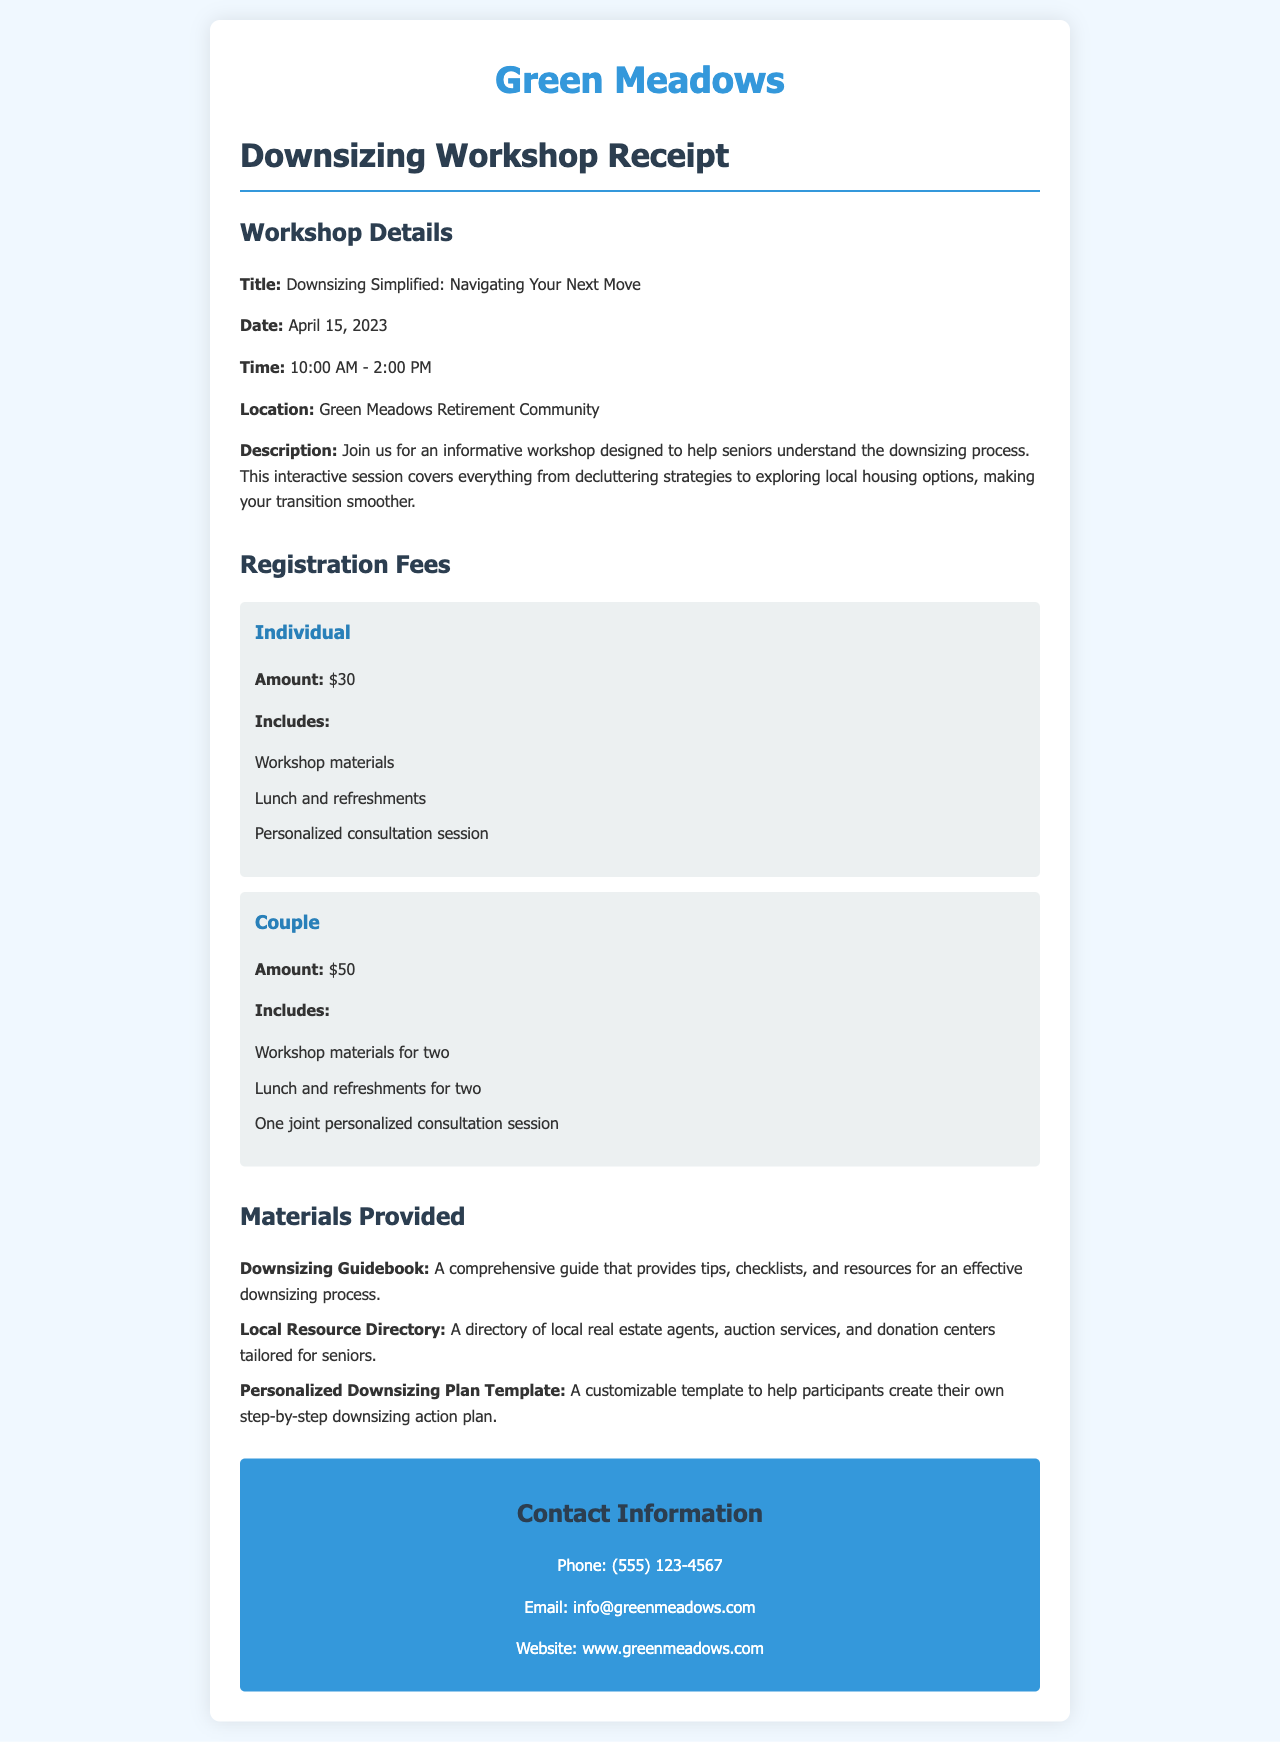What is the title of the workshop? The title of the workshop is specified in the document as "Downsizing Simplified: Navigating Your Next Move."
Answer: Downsizing Simplified: Navigating Your Next Move What is the date of the workshop? The document provides the date of the workshop as April 15, 2023.
Answer: April 15, 2023 What is the fee for a couple? The registration fees section lists the amount for a couple's fee as $50.
Answer: $50 What materials are provided? The document lists the materials provided including a Downsizing Guidebook, Local Resource Directory, and Personalized Downsizing Plan Template.
Answer: Downsizing Guidebook, Local Resource Directory, Personalized Downsizing Plan Template How long does the workshop last? The document indicates that the workshop runs from 10:00 AM to 2:00 PM, which means it lasts for 4 hours.
Answer: 4 hours What does the individual registration fee include? The individual registration fee includes workshop materials, lunch and refreshments, and a personalized consultation session.
Answer: Workshop materials, lunch and refreshments, personalized consultation session What is the location of the workshop? The document clearly states that the workshop will take place at the Green Meadows Retirement Community.
Answer: Green Meadows Retirement Community What kind of consultation is offered? The document specifies that a personalized consultation session is part of the fee options, distinguishing it as individual or joint for couples.
Answer: Personalized consultation session What contact methods are provided? The document includes phone, email, and website as contact methods.
Answer: Phone, email, website 